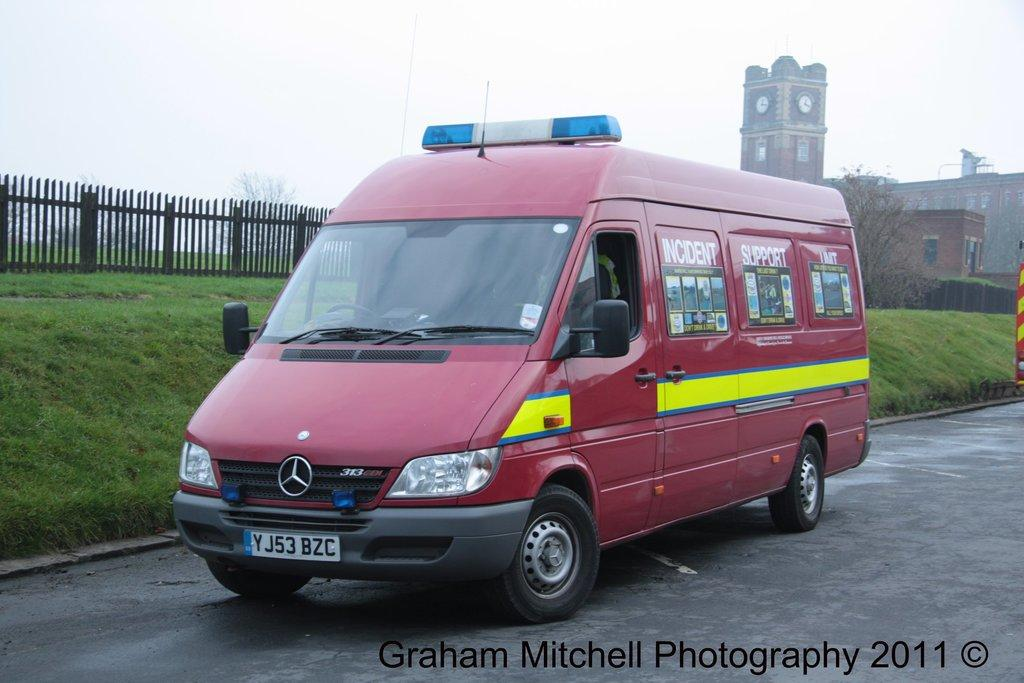<image>
Relay a brief, clear account of the picture shown. Red van with the word "Incident Support" on it. 